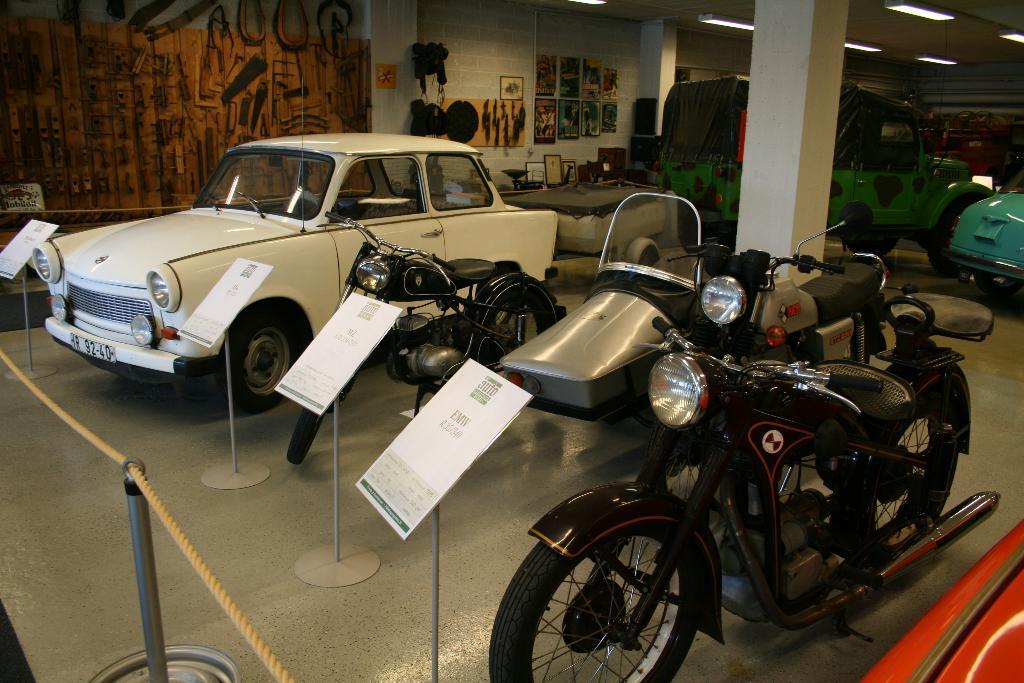Can you describe this image briefly? In this picture there are some bikes parked in the showroom. Beside there is a white color small classic car. Behind there is a green color jeep. In the background there is a white color wall with hanging photo frames. 